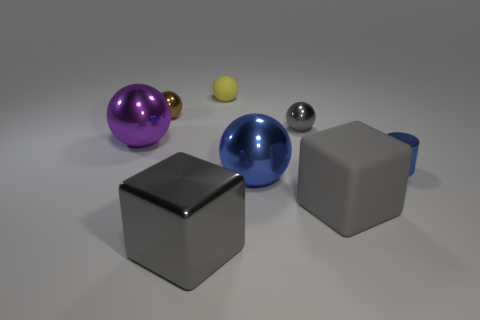What is the small yellow ball made of?
Make the answer very short. Rubber. There is a metal cylinder that is the same size as the brown shiny sphere; what is its color?
Offer a terse response. Blue. There is a rubber object behind the purple thing; is there a small cylinder that is in front of it?
Make the answer very short. Yes. What number of cubes are either big shiny things or gray rubber objects?
Offer a very short reply. 2. What is the size of the gray shiny thing in front of the purple metallic sphere left of the large shiny object that is in front of the large gray rubber object?
Keep it short and to the point. Large. Are there any brown objects right of the purple metal sphere?
Offer a terse response. Yes. The tiny metallic thing that is the same color as the big metallic block is what shape?
Give a very brief answer. Sphere. What number of objects are either blue metal things that are right of the small gray shiny sphere or yellow things?
Your answer should be compact. 2. The blue ball that is the same material as the big purple sphere is what size?
Your response must be concise. Large. There is a brown metallic sphere; does it have the same size as the gray shiny object in front of the gray rubber block?
Your answer should be compact. No. 